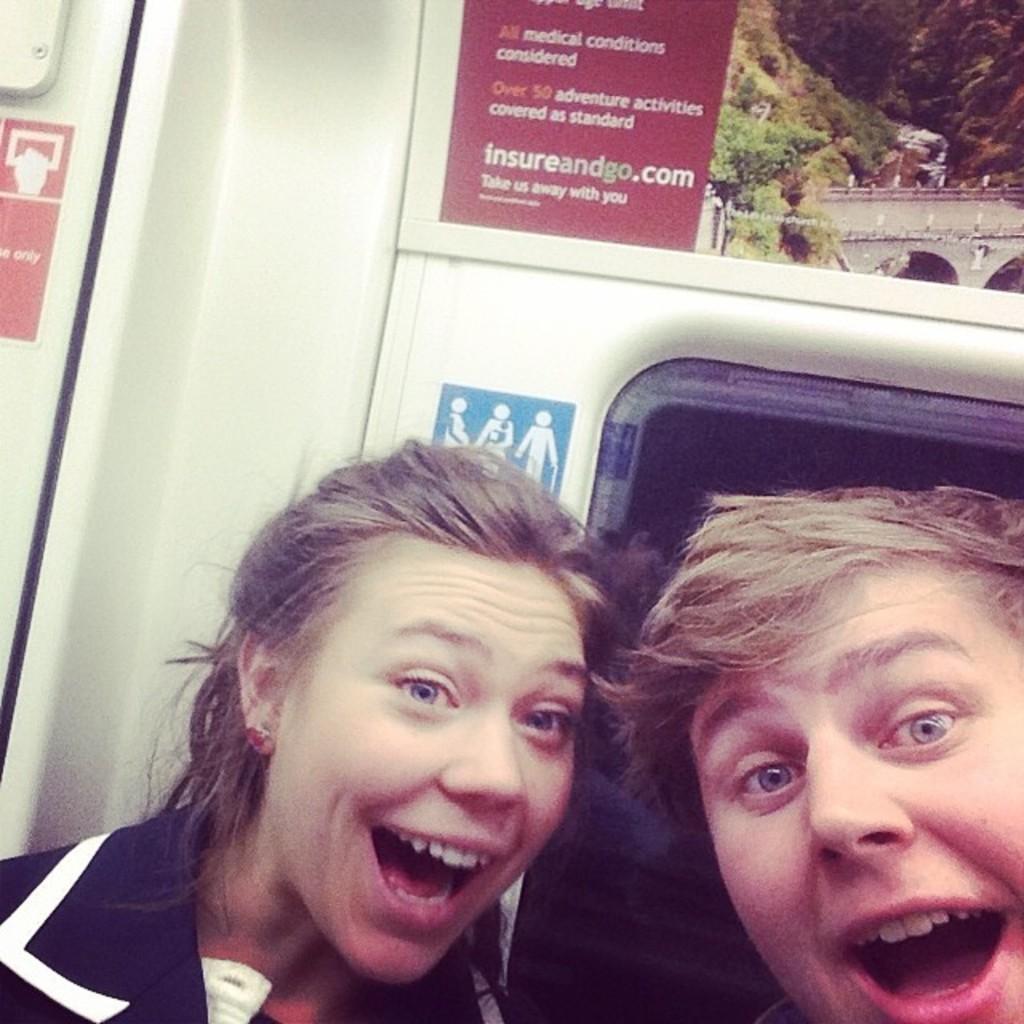Could you give a brief overview of what you see in this image? This image is taken in a vehicle. In the background there are a few posters with text on them. There is a signboard. There is a window. On the right side of the image there is a man. In the middle of the image there is a girl. 